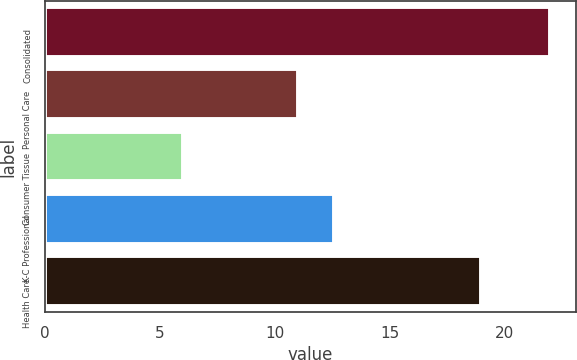Convert chart. <chart><loc_0><loc_0><loc_500><loc_500><bar_chart><fcel>Consolidated<fcel>Personal Care<fcel>Consumer Tissue<fcel>K-C Professional<fcel>Health Care<nl><fcel>22<fcel>11<fcel>6<fcel>12.6<fcel>19<nl></chart> 